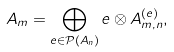Convert formula to latex. <formula><loc_0><loc_0><loc_500><loc_500>A _ { m } = \bigoplus _ { e \in \mathcal { P } ( A _ { n } ) } e \otimes A _ { m , n } ^ { ( e ) } ,</formula> 